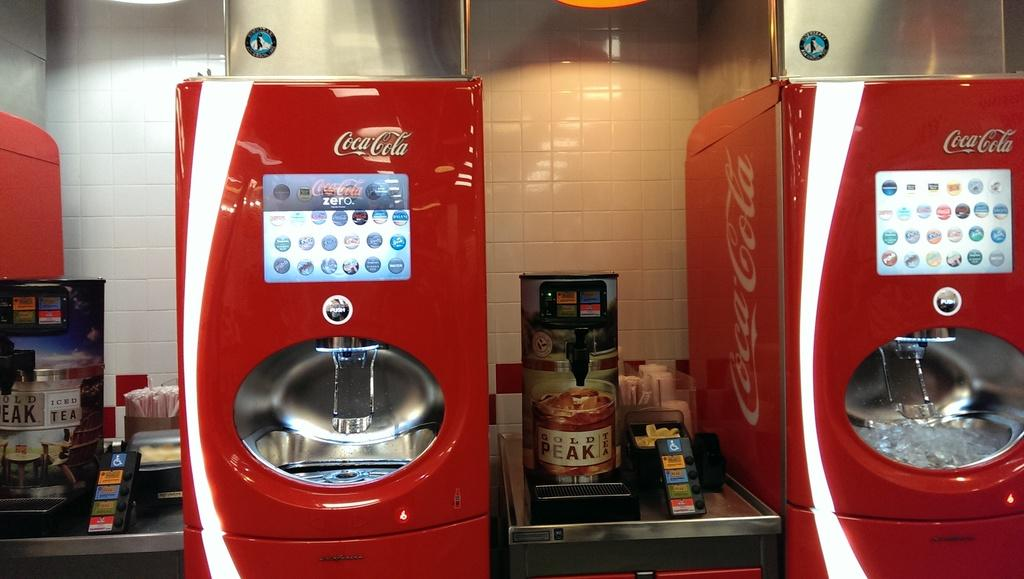<image>
Render a clear and concise summary of the photo. A large red Coca Cola machine sits next to a smaller Gold Peak Tea dispenser. 